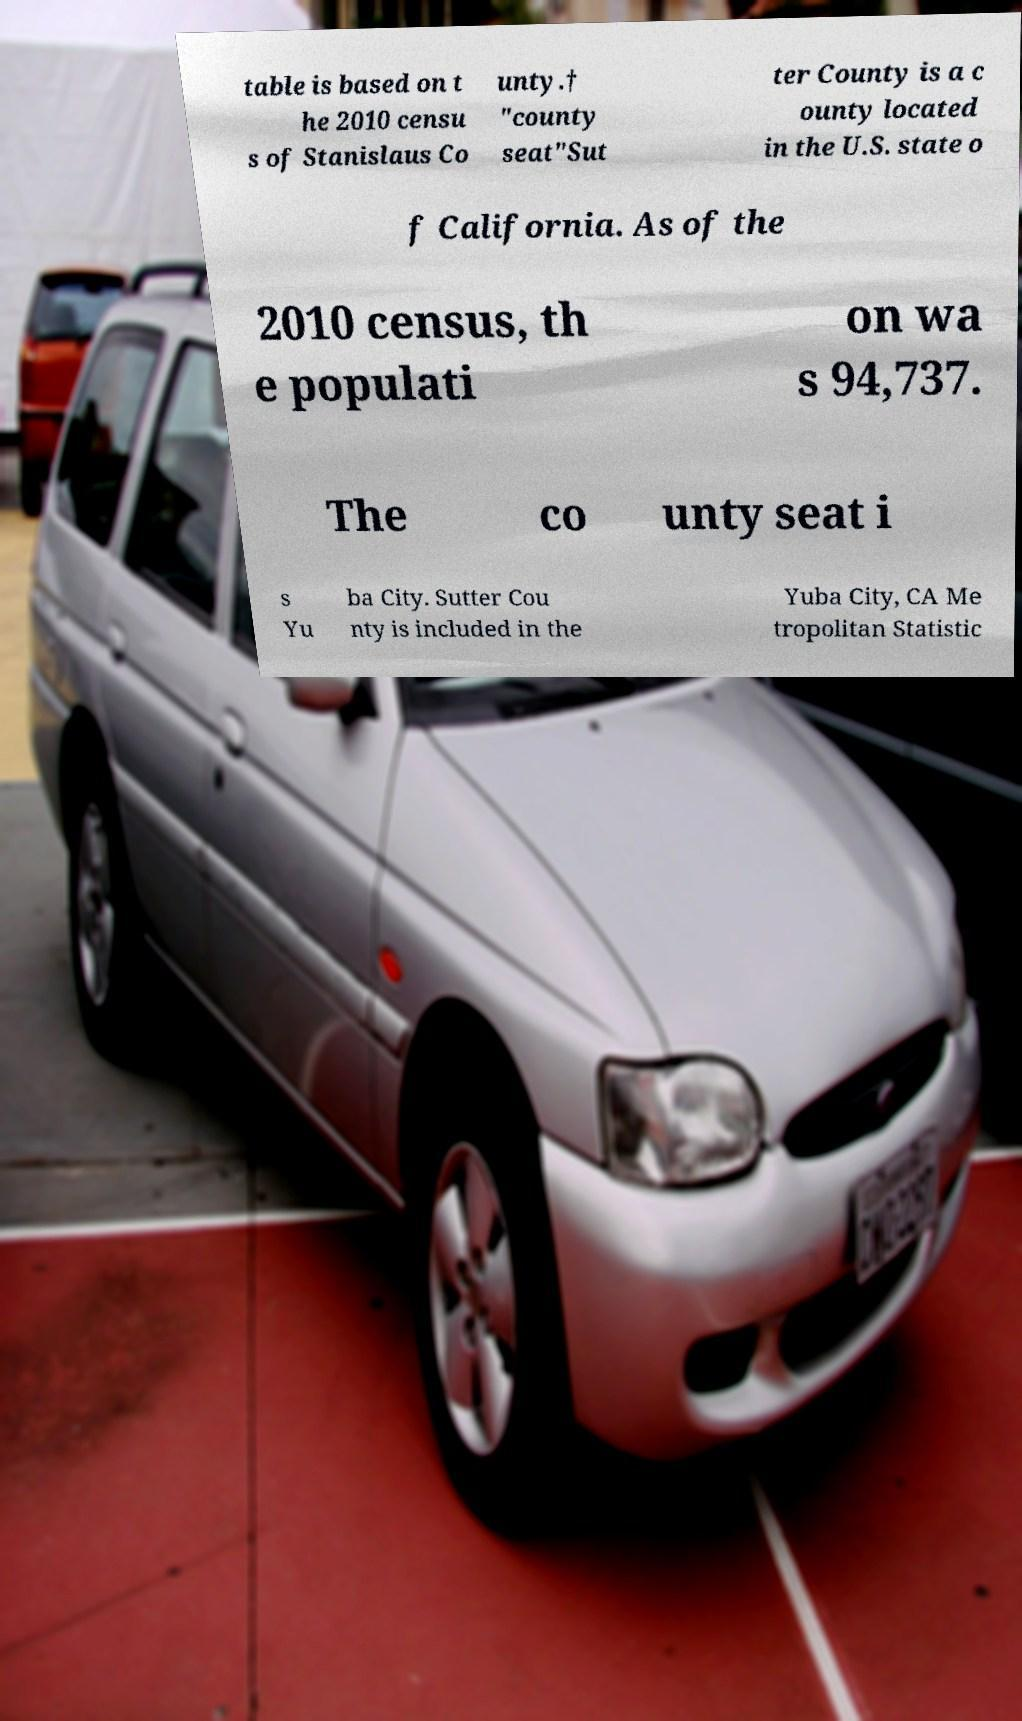There's text embedded in this image that I need extracted. Can you transcribe it verbatim? table is based on t he 2010 censu s of Stanislaus Co unty.† "county seat"Sut ter County is a c ounty located in the U.S. state o f California. As of the 2010 census, th e populati on wa s 94,737. The co unty seat i s Yu ba City. Sutter Cou nty is included in the Yuba City, CA Me tropolitan Statistic 